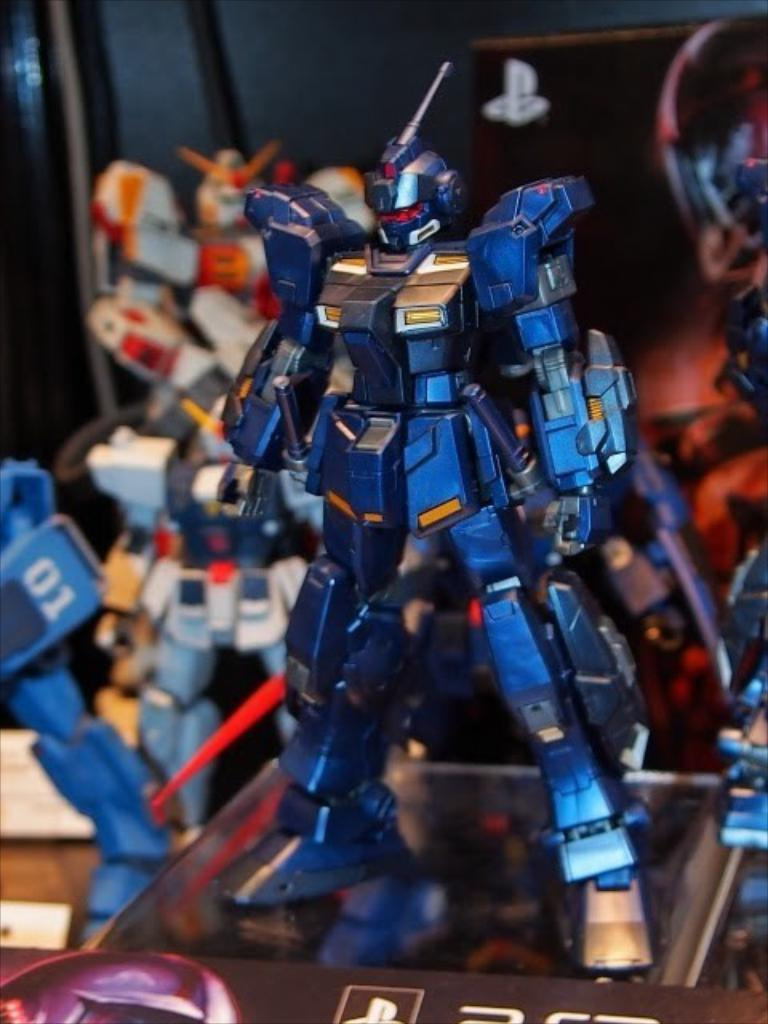What is the main subject of the picture? The main subject of the picture is a toy robot. Can you describe the color of the toy robot? The toy robot is blue in color. Are there any other toy robots visible in the picture? Yes, there are other toy robots visible behind the blue one. What type of tin can be seen in the sky in the image? There is no tin visible in the sky in the image, as the image only features toy robots. Can you describe the self-awareness of the toy robots in the image? The image does not provide any information about the self-awareness of the toy robots, as it is a still image and not a video or interactive medium. 